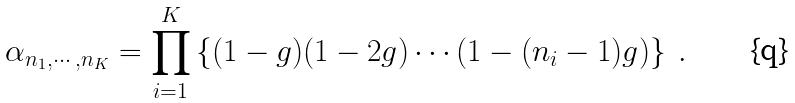<formula> <loc_0><loc_0><loc_500><loc_500>\alpha _ { n _ { 1 } , \cdots , n _ { K } } = \prod _ { i = 1 } ^ { K } \left \{ ( 1 - g ) ( 1 - 2 g ) \cdots ( 1 - ( n _ { i } - 1 ) g ) \right \} \ .</formula> 